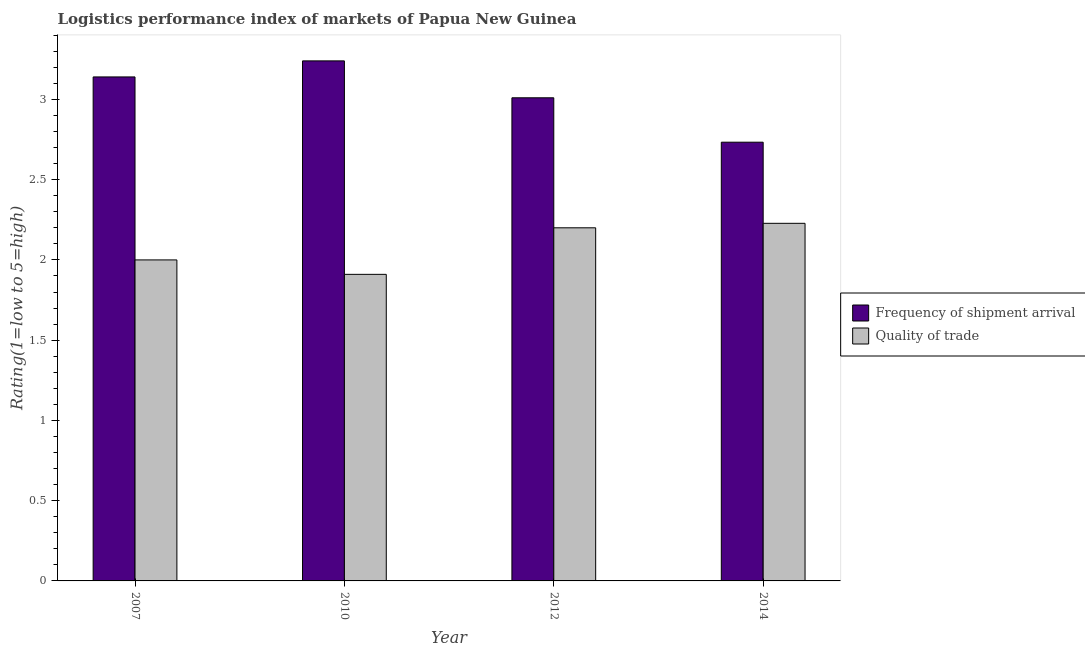How many groups of bars are there?
Offer a terse response. 4. Are the number of bars on each tick of the X-axis equal?
Make the answer very short. Yes. How many bars are there on the 3rd tick from the right?
Keep it short and to the point. 2. What is the lpi of frequency of shipment arrival in 2007?
Offer a terse response. 3.14. Across all years, what is the maximum lpi quality of trade?
Make the answer very short. 2.23. Across all years, what is the minimum lpi quality of trade?
Make the answer very short. 1.91. In which year was the lpi quality of trade maximum?
Your response must be concise. 2014. In which year was the lpi of frequency of shipment arrival minimum?
Offer a terse response. 2014. What is the total lpi of frequency of shipment arrival in the graph?
Your answer should be compact. 12.12. What is the difference between the lpi of frequency of shipment arrival in 2007 and that in 2010?
Offer a very short reply. -0.1. What is the difference between the lpi quality of trade in 2010 and the lpi of frequency of shipment arrival in 2014?
Provide a short and direct response. -0.32. What is the average lpi quality of trade per year?
Your answer should be compact. 2.08. What is the ratio of the lpi quality of trade in 2007 to that in 2010?
Offer a terse response. 1.05. Is the difference between the lpi of frequency of shipment arrival in 2007 and 2010 greater than the difference between the lpi quality of trade in 2007 and 2010?
Ensure brevity in your answer.  No. What is the difference between the highest and the second highest lpi of frequency of shipment arrival?
Your answer should be very brief. 0.1. What is the difference between the highest and the lowest lpi quality of trade?
Make the answer very short. 0.32. In how many years, is the lpi quality of trade greater than the average lpi quality of trade taken over all years?
Keep it short and to the point. 2. Is the sum of the lpi quality of trade in 2007 and 2012 greater than the maximum lpi of frequency of shipment arrival across all years?
Make the answer very short. Yes. What does the 1st bar from the left in 2012 represents?
Give a very brief answer. Frequency of shipment arrival. What does the 2nd bar from the right in 2014 represents?
Provide a succinct answer. Frequency of shipment arrival. Are all the bars in the graph horizontal?
Your answer should be very brief. No. Does the graph contain any zero values?
Provide a short and direct response. No. Does the graph contain grids?
Make the answer very short. No. How many legend labels are there?
Your answer should be very brief. 2. What is the title of the graph?
Your answer should be very brief. Logistics performance index of markets of Papua New Guinea. What is the label or title of the Y-axis?
Offer a terse response. Rating(1=low to 5=high). What is the Rating(1=low to 5=high) of Frequency of shipment arrival in 2007?
Keep it short and to the point. 3.14. What is the Rating(1=low to 5=high) in Quality of trade in 2007?
Make the answer very short. 2. What is the Rating(1=low to 5=high) in Frequency of shipment arrival in 2010?
Keep it short and to the point. 3.24. What is the Rating(1=low to 5=high) in Quality of trade in 2010?
Provide a short and direct response. 1.91. What is the Rating(1=low to 5=high) of Frequency of shipment arrival in 2012?
Your answer should be compact. 3.01. What is the Rating(1=low to 5=high) of Frequency of shipment arrival in 2014?
Give a very brief answer. 2.73. What is the Rating(1=low to 5=high) of Quality of trade in 2014?
Provide a short and direct response. 2.23. Across all years, what is the maximum Rating(1=low to 5=high) of Frequency of shipment arrival?
Your answer should be very brief. 3.24. Across all years, what is the maximum Rating(1=low to 5=high) of Quality of trade?
Your response must be concise. 2.23. Across all years, what is the minimum Rating(1=low to 5=high) in Frequency of shipment arrival?
Keep it short and to the point. 2.73. Across all years, what is the minimum Rating(1=low to 5=high) of Quality of trade?
Keep it short and to the point. 1.91. What is the total Rating(1=low to 5=high) of Frequency of shipment arrival in the graph?
Give a very brief answer. 12.12. What is the total Rating(1=low to 5=high) of Quality of trade in the graph?
Provide a short and direct response. 8.34. What is the difference between the Rating(1=low to 5=high) of Quality of trade in 2007 and that in 2010?
Provide a succinct answer. 0.09. What is the difference between the Rating(1=low to 5=high) in Frequency of shipment arrival in 2007 and that in 2012?
Ensure brevity in your answer.  0.13. What is the difference between the Rating(1=low to 5=high) in Frequency of shipment arrival in 2007 and that in 2014?
Offer a terse response. 0.41. What is the difference between the Rating(1=low to 5=high) of Quality of trade in 2007 and that in 2014?
Your answer should be compact. -0.23. What is the difference between the Rating(1=low to 5=high) in Frequency of shipment arrival in 2010 and that in 2012?
Your answer should be very brief. 0.23. What is the difference between the Rating(1=low to 5=high) of Quality of trade in 2010 and that in 2012?
Keep it short and to the point. -0.29. What is the difference between the Rating(1=low to 5=high) of Frequency of shipment arrival in 2010 and that in 2014?
Provide a succinct answer. 0.51. What is the difference between the Rating(1=low to 5=high) in Quality of trade in 2010 and that in 2014?
Make the answer very short. -0.32. What is the difference between the Rating(1=low to 5=high) in Frequency of shipment arrival in 2012 and that in 2014?
Ensure brevity in your answer.  0.28. What is the difference between the Rating(1=low to 5=high) in Quality of trade in 2012 and that in 2014?
Make the answer very short. -0.03. What is the difference between the Rating(1=low to 5=high) in Frequency of shipment arrival in 2007 and the Rating(1=low to 5=high) in Quality of trade in 2010?
Provide a short and direct response. 1.23. What is the difference between the Rating(1=low to 5=high) in Frequency of shipment arrival in 2007 and the Rating(1=low to 5=high) in Quality of trade in 2012?
Offer a terse response. 0.94. What is the difference between the Rating(1=low to 5=high) in Frequency of shipment arrival in 2007 and the Rating(1=low to 5=high) in Quality of trade in 2014?
Provide a succinct answer. 0.91. What is the difference between the Rating(1=low to 5=high) of Frequency of shipment arrival in 2010 and the Rating(1=low to 5=high) of Quality of trade in 2012?
Your answer should be compact. 1.04. What is the difference between the Rating(1=low to 5=high) in Frequency of shipment arrival in 2010 and the Rating(1=low to 5=high) in Quality of trade in 2014?
Provide a short and direct response. 1.01. What is the difference between the Rating(1=low to 5=high) in Frequency of shipment arrival in 2012 and the Rating(1=low to 5=high) in Quality of trade in 2014?
Offer a terse response. 0.78. What is the average Rating(1=low to 5=high) in Frequency of shipment arrival per year?
Keep it short and to the point. 3.03. What is the average Rating(1=low to 5=high) of Quality of trade per year?
Your answer should be compact. 2.08. In the year 2007, what is the difference between the Rating(1=low to 5=high) of Frequency of shipment arrival and Rating(1=low to 5=high) of Quality of trade?
Provide a short and direct response. 1.14. In the year 2010, what is the difference between the Rating(1=low to 5=high) in Frequency of shipment arrival and Rating(1=low to 5=high) in Quality of trade?
Provide a short and direct response. 1.33. In the year 2012, what is the difference between the Rating(1=low to 5=high) in Frequency of shipment arrival and Rating(1=low to 5=high) in Quality of trade?
Offer a very short reply. 0.81. In the year 2014, what is the difference between the Rating(1=low to 5=high) in Frequency of shipment arrival and Rating(1=low to 5=high) in Quality of trade?
Give a very brief answer. 0.51. What is the ratio of the Rating(1=low to 5=high) in Frequency of shipment arrival in 2007 to that in 2010?
Give a very brief answer. 0.97. What is the ratio of the Rating(1=low to 5=high) in Quality of trade in 2007 to that in 2010?
Provide a succinct answer. 1.05. What is the ratio of the Rating(1=low to 5=high) in Frequency of shipment arrival in 2007 to that in 2012?
Your answer should be very brief. 1.04. What is the ratio of the Rating(1=low to 5=high) in Frequency of shipment arrival in 2007 to that in 2014?
Provide a short and direct response. 1.15. What is the ratio of the Rating(1=low to 5=high) in Quality of trade in 2007 to that in 2014?
Ensure brevity in your answer.  0.9. What is the ratio of the Rating(1=low to 5=high) in Frequency of shipment arrival in 2010 to that in 2012?
Ensure brevity in your answer.  1.08. What is the ratio of the Rating(1=low to 5=high) of Quality of trade in 2010 to that in 2012?
Provide a short and direct response. 0.87. What is the ratio of the Rating(1=low to 5=high) in Frequency of shipment arrival in 2010 to that in 2014?
Provide a short and direct response. 1.19. What is the ratio of the Rating(1=low to 5=high) of Quality of trade in 2010 to that in 2014?
Offer a very short reply. 0.86. What is the ratio of the Rating(1=low to 5=high) of Frequency of shipment arrival in 2012 to that in 2014?
Provide a succinct answer. 1.1. What is the ratio of the Rating(1=low to 5=high) in Quality of trade in 2012 to that in 2014?
Make the answer very short. 0.99. What is the difference between the highest and the second highest Rating(1=low to 5=high) in Quality of trade?
Ensure brevity in your answer.  0.03. What is the difference between the highest and the lowest Rating(1=low to 5=high) in Frequency of shipment arrival?
Make the answer very short. 0.51. What is the difference between the highest and the lowest Rating(1=low to 5=high) in Quality of trade?
Your answer should be very brief. 0.32. 